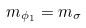<formula> <loc_0><loc_0><loc_500><loc_500>m _ { \phi _ { 1 } } = m _ { \sigma }</formula> 